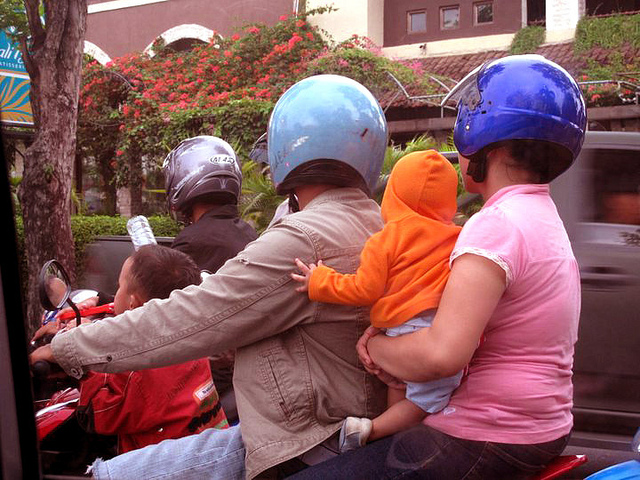Extract all visible text content from this image. li 